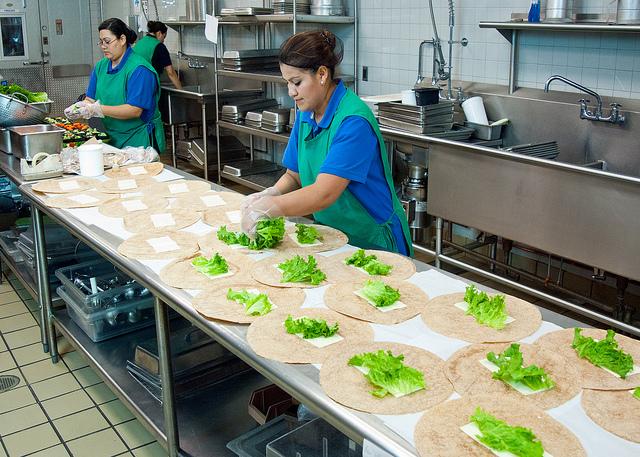Do the workers appear to be following basic food safety protocol?
Write a very short answer. Yes. Is that lettuce on the plate?
Keep it brief. Yes. What color aprons are the people wearing?
Write a very short answer. Green. 